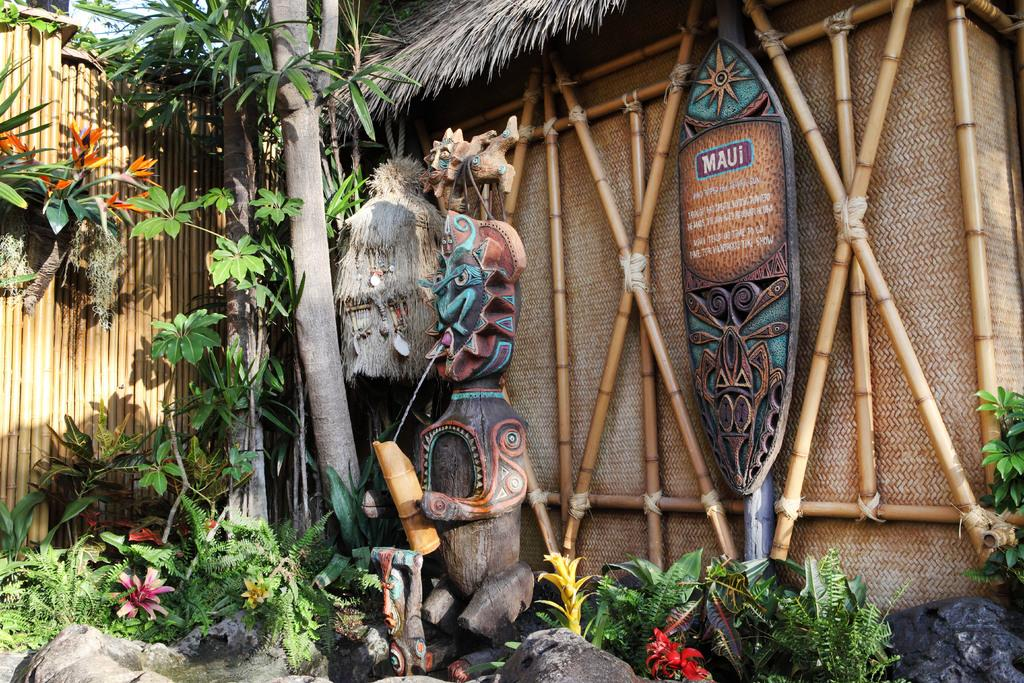What is the main feature in the image? There is a fountain in the image. What is located near the fountain? There are plants beside the fountain. What type of vegetation can be seen in the image? There are trees in the image. What type of structure is present in the image? There is a hut in the image. What cast members are present in the image? There are no cast members present in the image, as it features a fountain, plants, trees, and a hut. What arithmetic problem can be solved using the number of trees in the image? There is no arithmetic problem related to the number of trees in the image, as the focus is on describing the elements present in the image. 